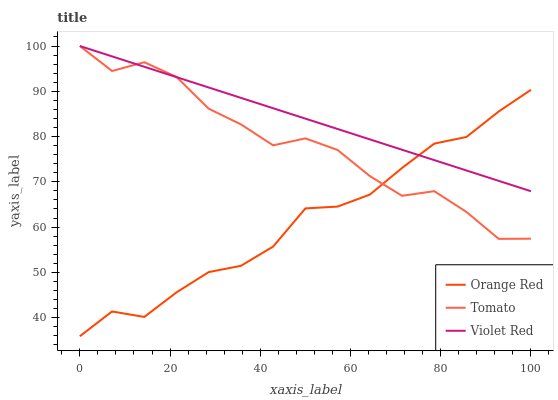Does Violet Red have the minimum area under the curve?
Answer yes or no. No. Does Orange Red have the maximum area under the curve?
Answer yes or no. No. Is Orange Red the smoothest?
Answer yes or no. No. Is Orange Red the roughest?
Answer yes or no. No. Does Violet Red have the lowest value?
Answer yes or no. No. Does Orange Red have the highest value?
Answer yes or no. No. 